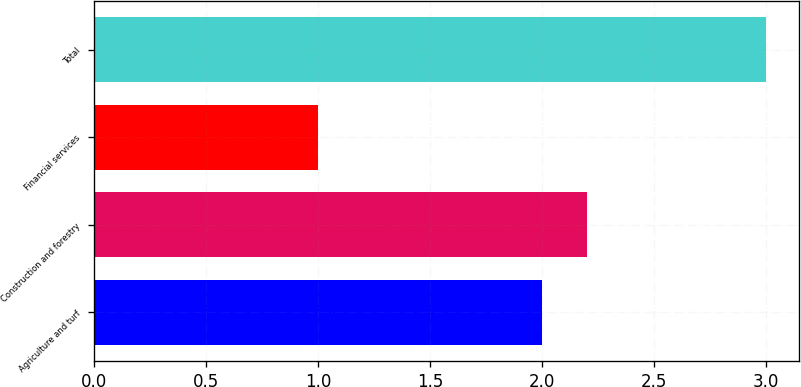Convert chart to OTSL. <chart><loc_0><loc_0><loc_500><loc_500><bar_chart><fcel>Agriculture and turf<fcel>Construction and forestry<fcel>Financial services<fcel>Total<nl><fcel>2<fcel>2.2<fcel>1<fcel>3<nl></chart> 